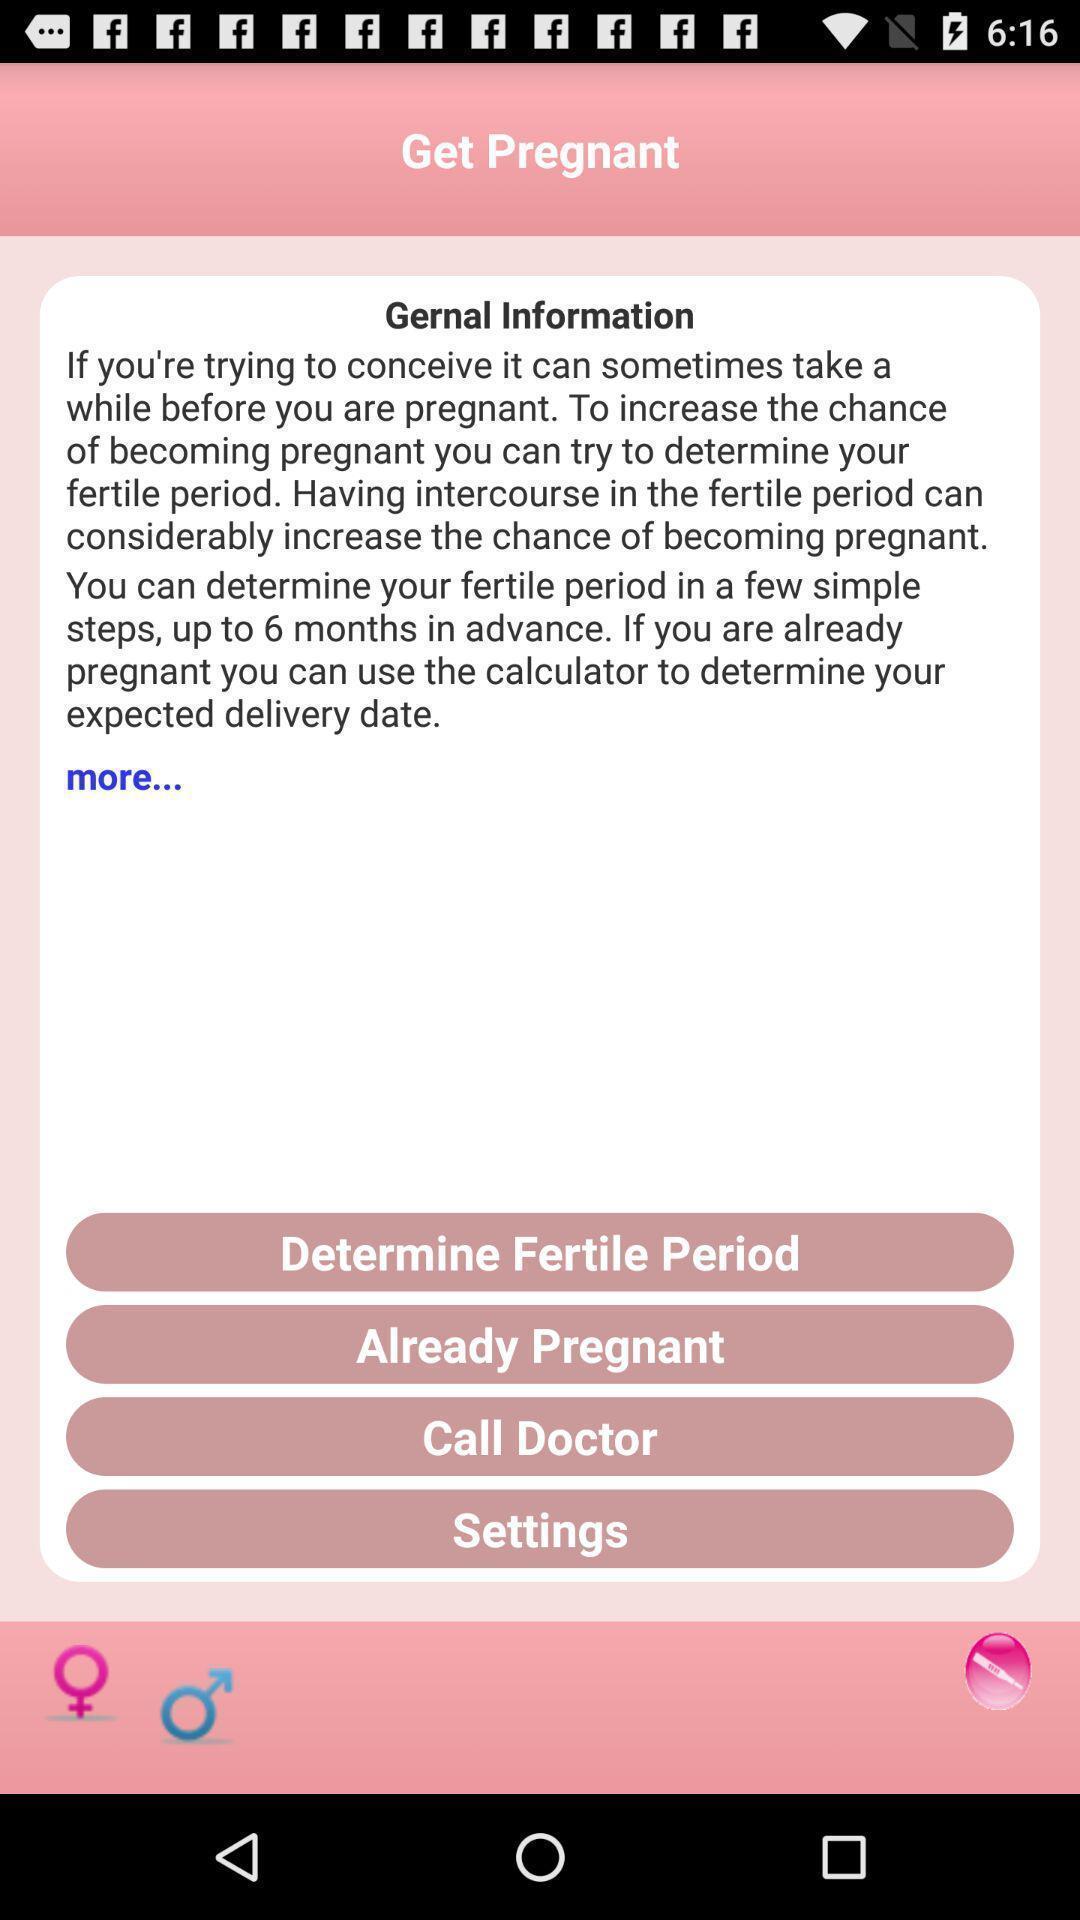Give me a summary of this screen capture. Page for the general health information. 